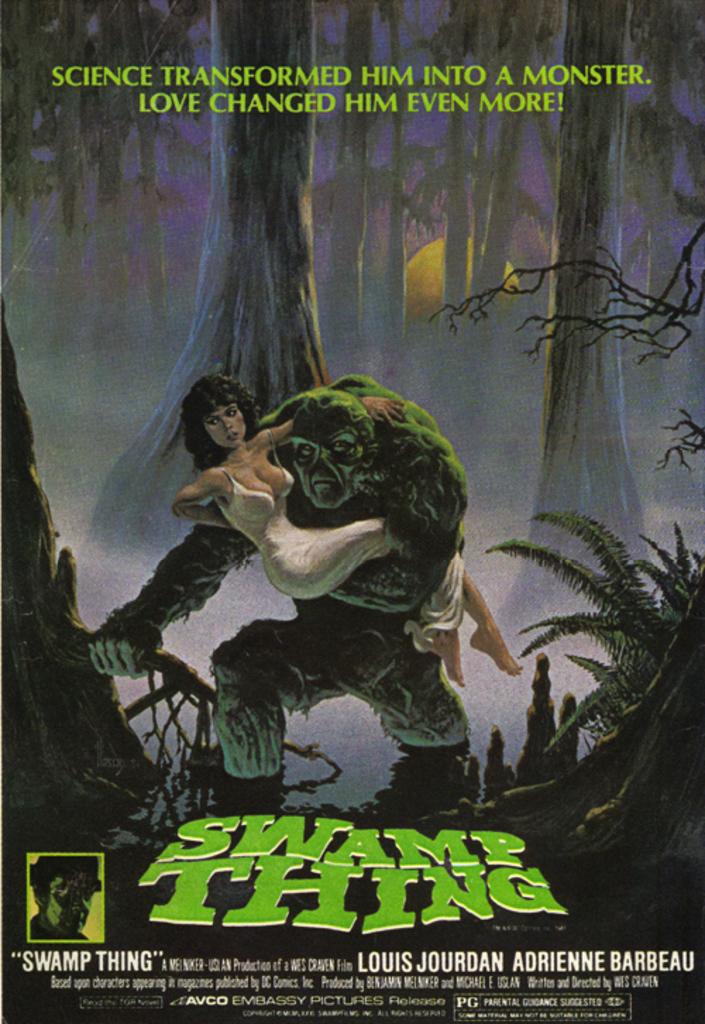What is the title of the movie?
Offer a very short reply. Swamp thing. What is one of the actors/actresses in this film?
Provide a succinct answer. Louis jourdan. 